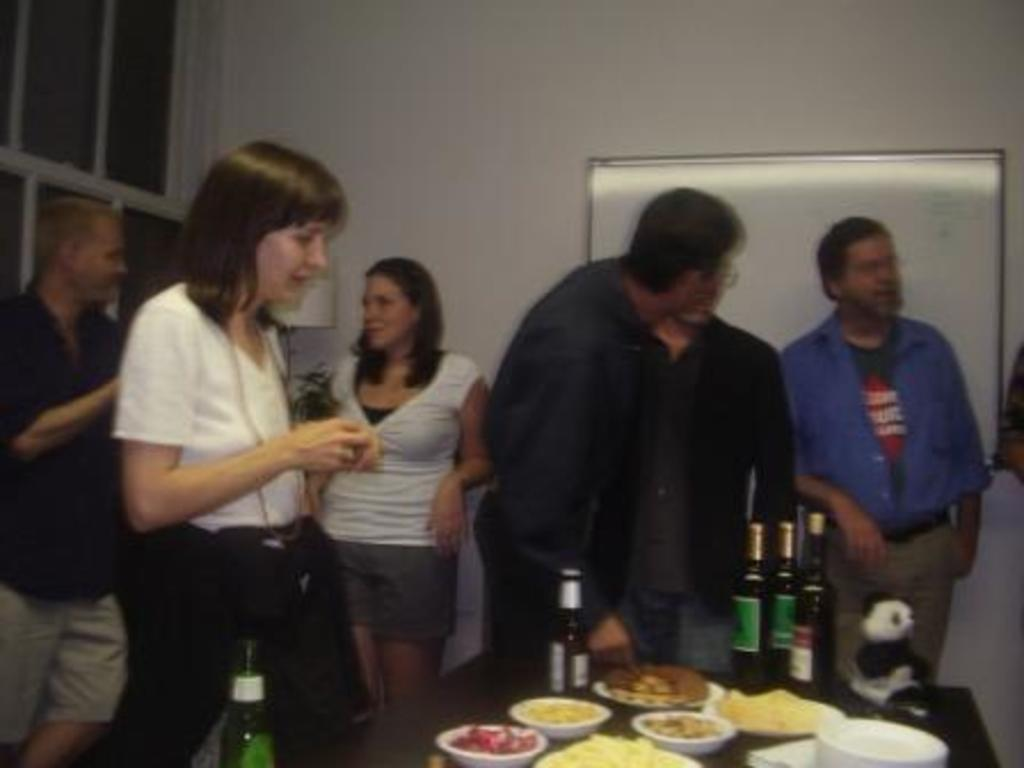Who or what can be seen in the image? There are people in the image. What is the color of the wall in the image? There is a white color wall in the image. What type of furniture is present in the image? There are cupboards and a table in the image. What objects are on the table? There are bowls, bottles, and food items on the table. Is the queen present in the image? There is no queen present in the image. What property is being discussed in the image? The image does not depict any property or real estate; it shows people, a wall, cupboards, a table, and objects on the table. 